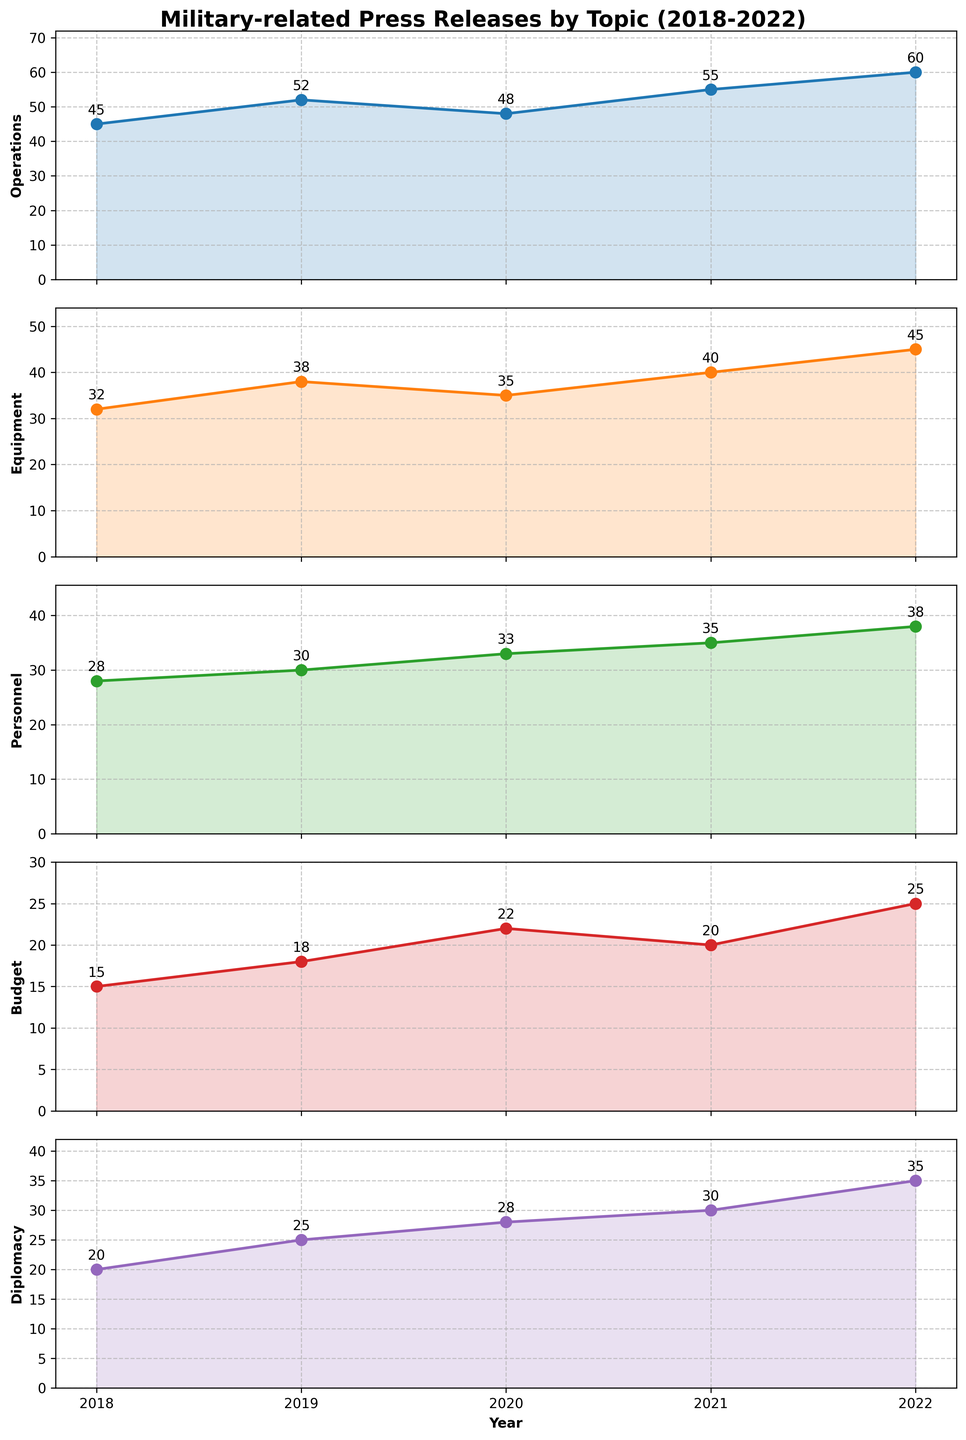What is the title of the figure? The title is given at the top of the figure and summarizes the data being presented. It reads "Military-related Press Releases by Topic (2018-2022)" which provides context about the subjects and the time period covered.
Answer: Military-related Press Releases by Topic (2018-2022) Which topic category had the highest frequency of press releases in 2022? Observing the year's data points in each subplot, 2022 shows that the category "Operations" had the highest value at 60, which is higher than any other category in that year.
Answer: Operations How many categories are tracked in this figure? The figure has five subplots, each representing different categories. They are labeled as Operations, Equipment, Personnel, Budget, and Diplomacy.
Answer: Five What year saw the highest frequency of press releases related to Equipment? Looking at the Equipment plot, the highest frequency is seen in 2022, where the value is 45.
Answer: 2022 What is the overall trend in press releases related to Budget from 2018 to 2022? The trend for Budget can be determined by observing the change in values over the years. The numbers rise from 15 in 2018, peak in 2020 at 22, dip to 20 in 2021, and then increase to 25 in 2022.
Answer: Increasing overall with a dip in 2021 Which two categories had exactly the same frequency in any given year and what is that value? Comparing values year by year, in 2019 both Personnel and Diplomacy have press releases at 30.
Answer: Personnel and Diplomacy with a frequency of 30 in 2019 Calculate the average number of press releases for the Operations category over the five years. The average is calculated by summing all the values for Operations (45 + 52 + 48 + 55 + 60) which equals 260, and then dividing by 5 years. So, 260 / 5 = 52.
Answer: 52 Which category showed the most growth in frequency of press releases from 2018 to 2022? To determine the growth, subtract the 2018 value from the 2022 value for each category. Diplomacy has the highest growth, increasing from 20 in 2018 to 35 in 2022.
Answer: Diplomacy In which year did the Personnel category see its highest frequency of press releases and what was the value? Looking at the Personnel subplot, the highest value is in 2022 with a frequency of 38.
Answer: 2022 with 38 Between 2021 and 2022, which category saw the smallest increase in the frequency of press releases? To find this, subtract the 2021 value from the 2022 value for each category. Budget increases from 20 to 25, which is a change of 5, and this is the smallest increase.
Answer: Budget 